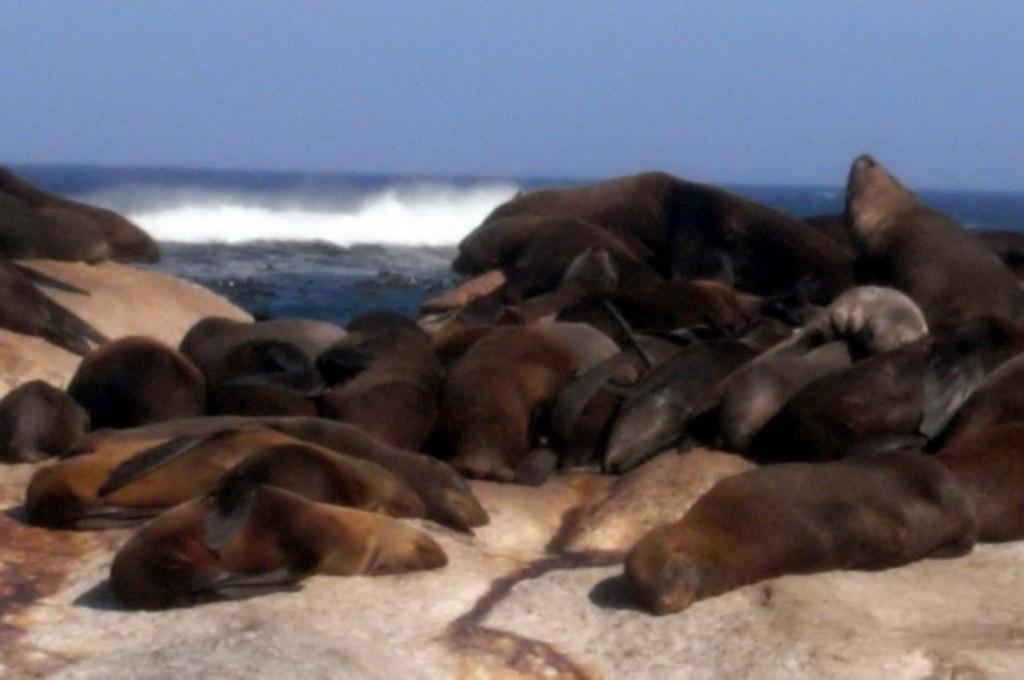What animals are on the rock in the image? There are seals on a rock in the image. What is visible behind the seals? There is water visible behind the seals. What is the condition of the sky in the image? The sky is clear in the image. What type of railway can be seen in the image? There is no railway present in the image; it features seals on a rock with water and a clear sky in the background. What color is the tail of the seals in the image? Seals do not have tails, so there is no tail to describe in the image. 